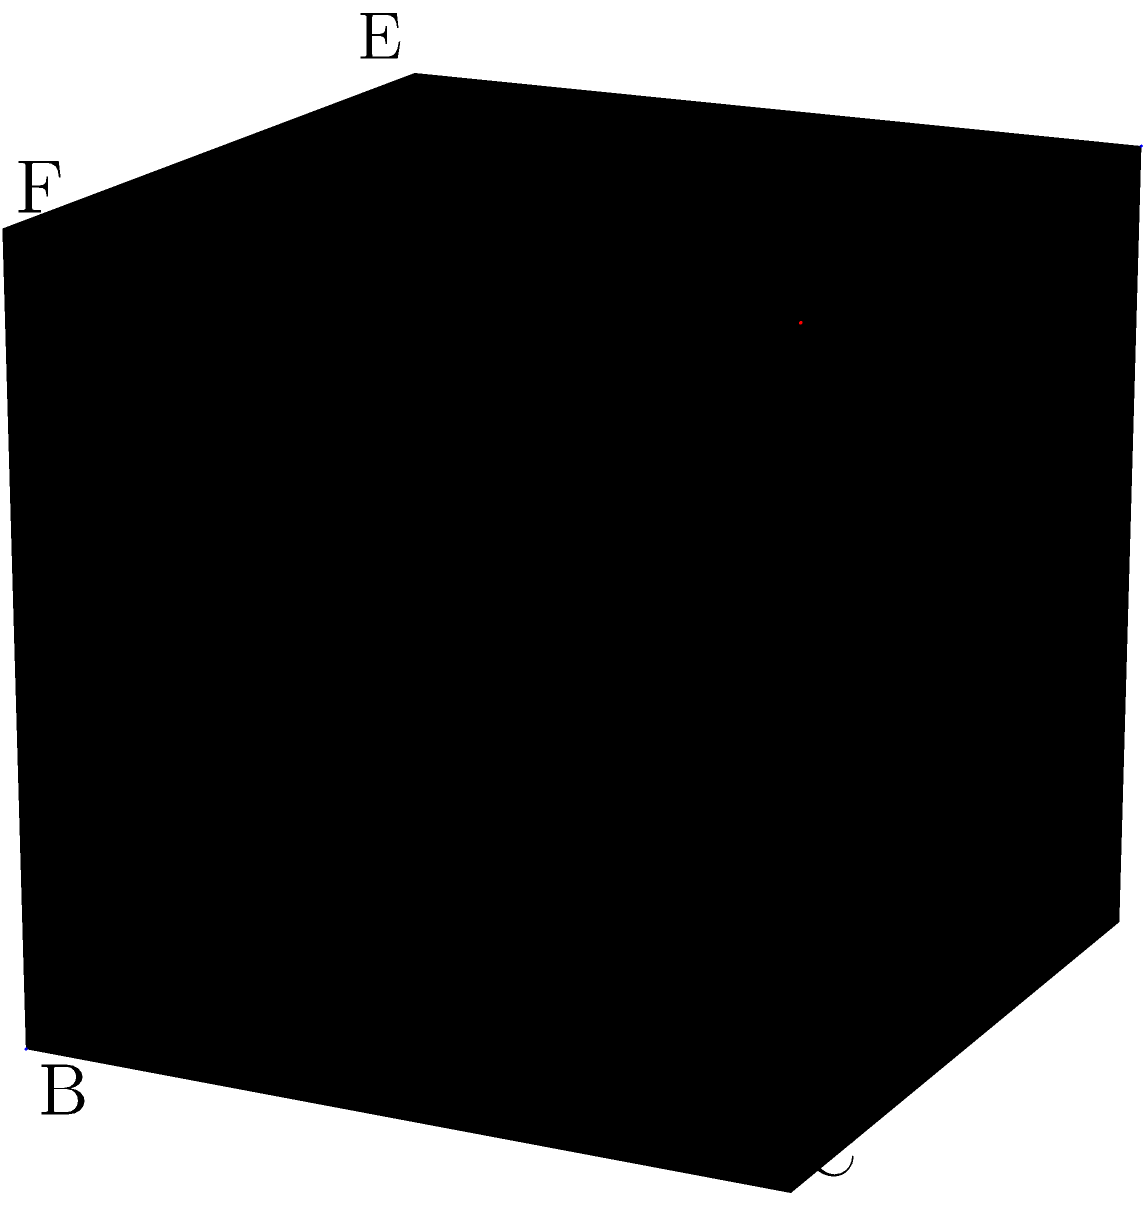In your quest to uncover hidden literary gems, you've stumbled upon a peculiar puzzle box in an old bookstore. The box, shaped like a unit cube, has two intersecting planes within it. One plane passes through points A, G, and F, while the other passes through points B, H, and G. What is the angle between these two planes? To find the angle between two intersecting planes, we can use the following steps:

1) First, we need to find the normal vectors of both planes:

   For plane AGF: $\vec{n_1} = \vec{AG} \times \vec{AF}$
   For plane BHG: $\vec{n_2} = \vec{BH} \times \vec{BG}$

2) The vectors are:
   $\vec{AG} = (1,1,1)$, $\vec{AF} = (1,0,1)$
   $\vec{BH} = (-1,1,1)$, $\vec{BG} = (0,1,1)$

3) Calculate the cross products:
   $\vec{n_1} = (1,1,1) \times (1,0,1) = (1,-1,0)$
   $\vec{n_2} = (-1,1,1) \times (0,1,1) = (-1,-1,1)$

4) The angle between the planes is the same as the angle between their normal vectors. We can find this using the dot product formula:

   $\cos \theta = \frac{\vec{n_1} \cdot \vec{n_2}}{|\vec{n_1}||\vec{n_2}|}$

5) Calculate the dot product and magnitudes:
   $\vec{n_1} \cdot \vec{n_2} = 1(-1) + (-1)(-1) + 0(1) = 0$
   $|\vec{n_1}| = \sqrt{1^2 + (-1)^2 + 0^2} = \sqrt{2}$
   $|\vec{n_2}| = \sqrt{(-1)^2 + (-1)^2 + 1^2} = \sqrt{3}$

6) Substitute into the formula:
   $\cos \theta = \frac{0}{\sqrt{2}\sqrt{3}} = 0$

7) Therefore, $\theta = \arccos(0) = 90°$
Answer: 90° 